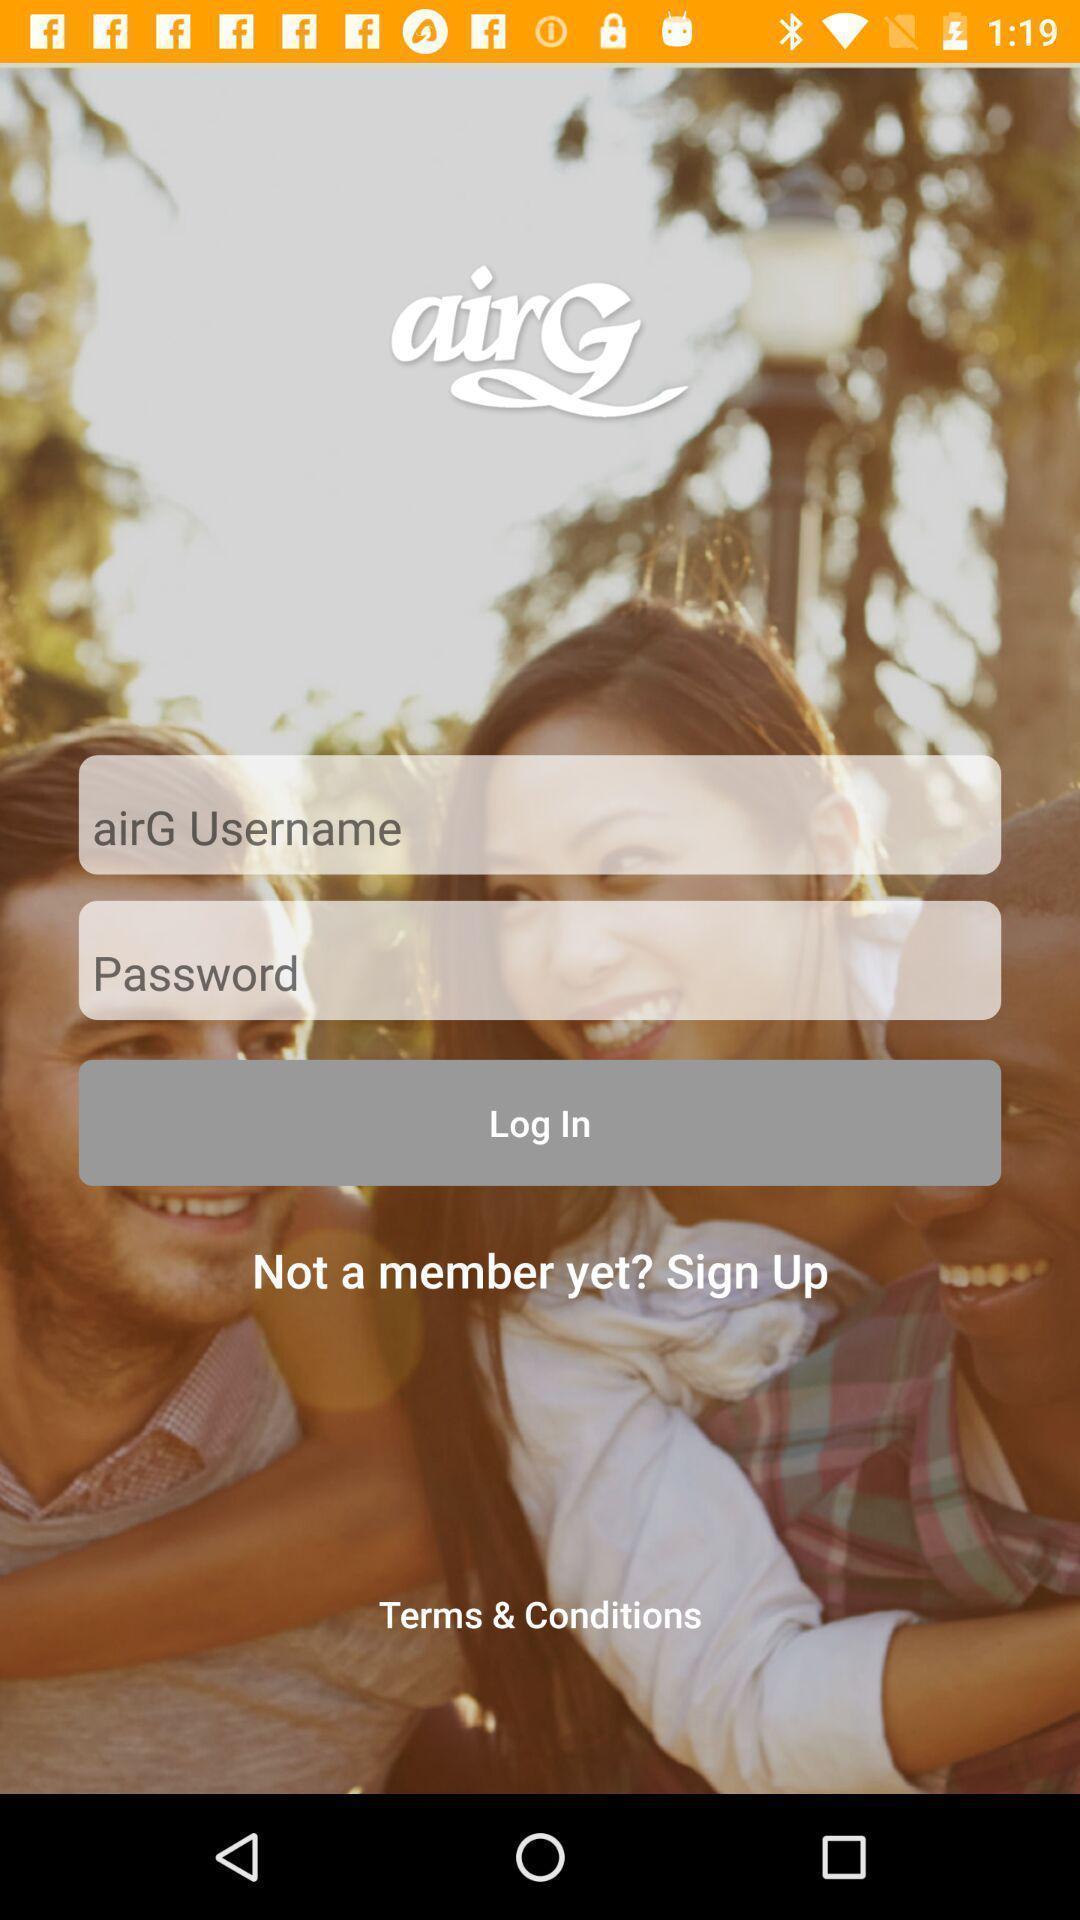Summarize the information in this screenshot. Welcome page for an app. 